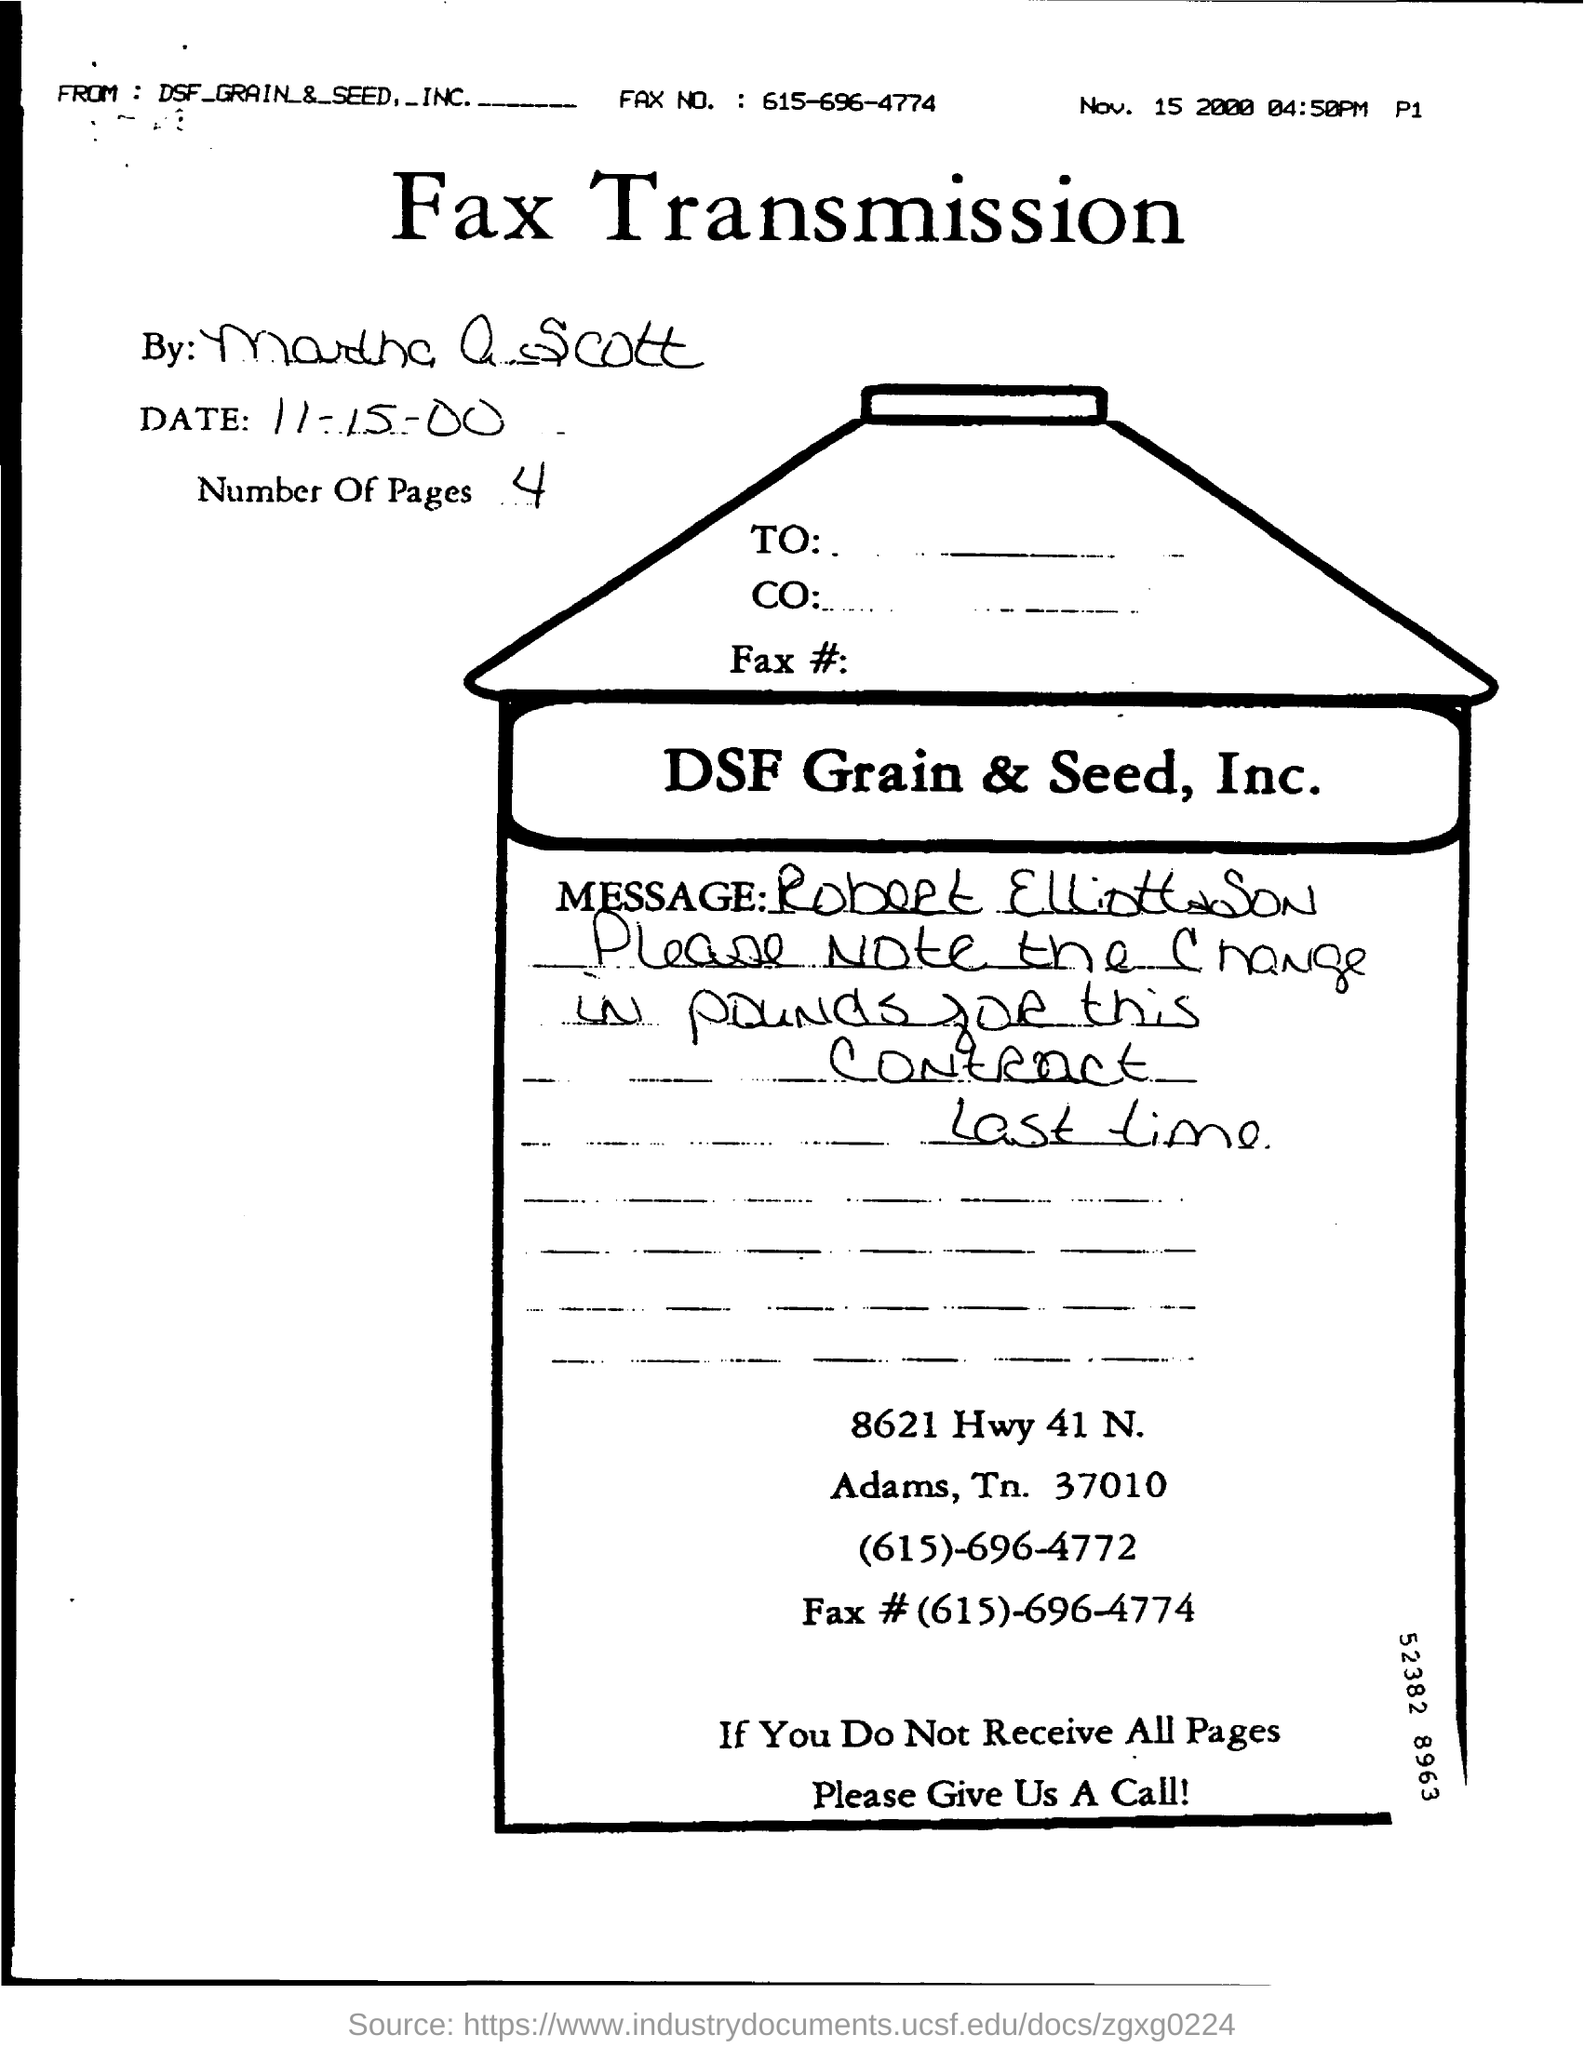Specify some key components in this picture. The FAX number mentioned is (615)-696-4774. There are 4 pages in the fax. There are 4 pages in the fax. This is a fax transmission. The date of the fax transmission was November 15, 2000. 